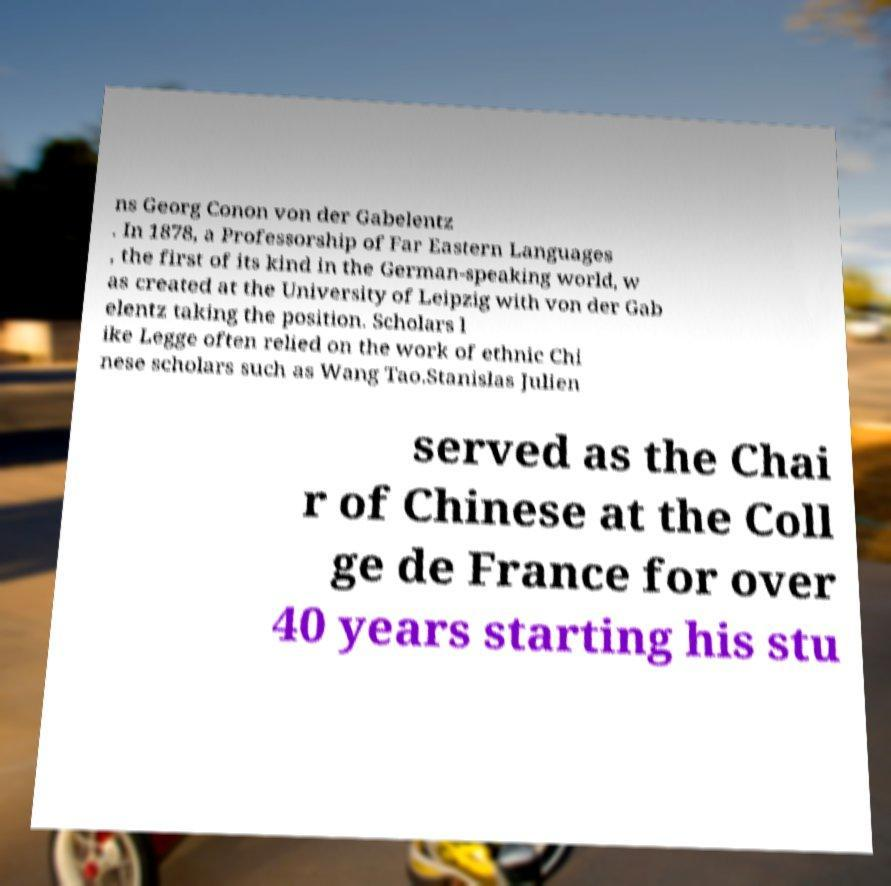For documentation purposes, I need the text within this image transcribed. Could you provide that? ns Georg Conon von der Gabelentz . In 1878, a Professorship of Far Eastern Languages , the first of its kind in the German-speaking world, w as created at the University of Leipzig with von der Gab elentz taking the position. Scholars l ike Legge often relied on the work of ethnic Chi nese scholars such as Wang Tao.Stanislas Julien served as the Chai r of Chinese at the Coll ge de France for over 40 years starting his stu 